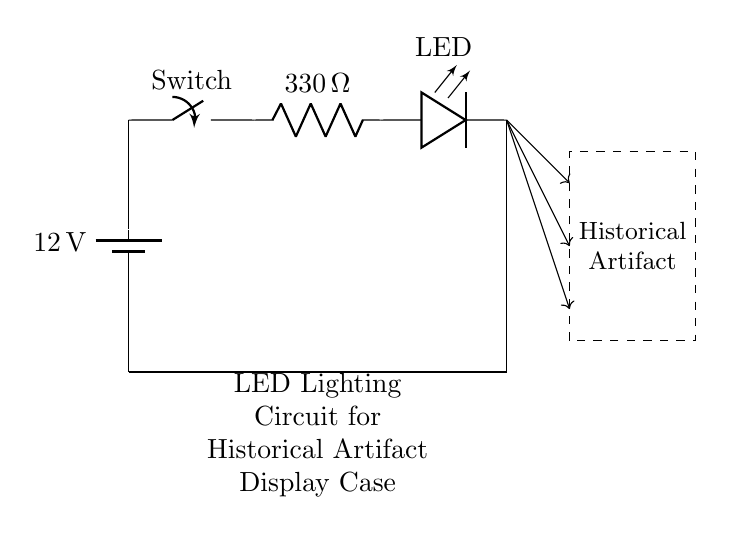What is the voltage of this circuit? The voltage is 12 volts, which is provided by the battery connected in the circuit.
Answer: 12 volts What type of component is used to limit current in this circuit? The current limiting component is a resistor labeled as 330 ohms, which is placed in series after the switch.
Answer: Resistor What happens when the switch is turned off? When the switch is turned off, the circuit is incomplete, preventing current from flowing to the LED, thus it will not illuminate.
Answer: LED off What is the purpose of the LED in this circuit? The purpose of the LED is to provide illumination to the display case where the historical artifact is located.
Answer: Illumination How many LEDs are shown in the circuit? There is one LED depicted in the circuit diagram that represents the lighting for the historical artifact display.
Answer: One Why is a current limiting resistor necessary in this circuit? A current limiting resistor is necessary to prevent excess current from damaging the LED, ensuring it operates within a safe current range.
Answer: To protect the LED Which direction does the light beam from the LED point towards? The light beams are shown pointing towards the dashed rectangle, representing the historical artifact inside the display case.
Answer: Towards the artifact 